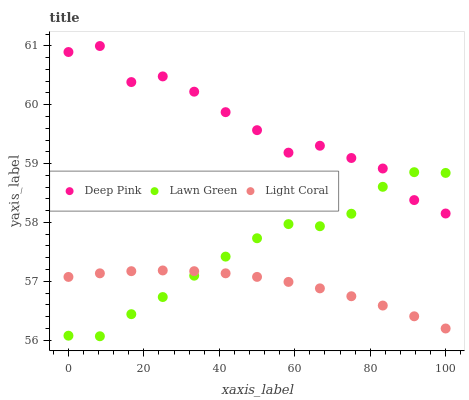Does Light Coral have the minimum area under the curve?
Answer yes or no. Yes. Does Deep Pink have the maximum area under the curve?
Answer yes or no. Yes. Does Lawn Green have the minimum area under the curve?
Answer yes or no. No. Does Lawn Green have the maximum area under the curve?
Answer yes or no. No. Is Light Coral the smoothest?
Answer yes or no. Yes. Is Deep Pink the roughest?
Answer yes or no. Yes. Is Lawn Green the smoothest?
Answer yes or no. No. Is Lawn Green the roughest?
Answer yes or no. No. Does Lawn Green have the lowest value?
Answer yes or no. Yes. Does Deep Pink have the lowest value?
Answer yes or no. No. Does Deep Pink have the highest value?
Answer yes or no. Yes. Does Lawn Green have the highest value?
Answer yes or no. No. Is Light Coral less than Deep Pink?
Answer yes or no. Yes. Is Deep Pink greater than Light Coral?
Answer yes or no. Yes. Does Lawn Green intersect Deep Pink?
Answer yes or no. Yes. Is Lawn Green less than Deep Pink?
Answer yes or no. No. Is Lawn Green greater than Deep Pink?
Answer yes or no. No. Does Light Coral intersect Deep Pink?
Answer yes or no. No. 